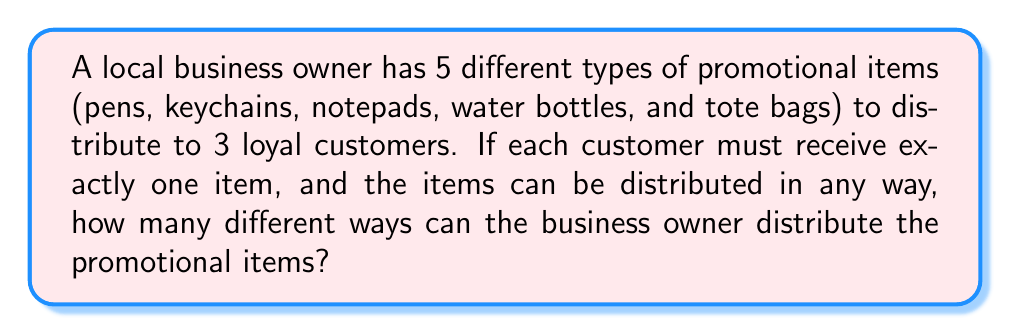Can you solve this math problem? Let's approach this step-by-step:

1) This is a permutation problem, as the order of distribution matters (each customer receives a specific item).

2) For the first customer, there are 5 choices of items.

3) After the first item is given, there are 4 choices left for the second customer.

4) For the last customer, there are 3 choices remaining.

5) According to the multiplication principle, we multiply these numbers together:

   $$5 \times 4 \times 3 = 60$$

6) This can also be expressed as a permutation:

   $$P(5,3) = \frac{5!}{(5-3)!} = \frac{5!}{2!} = 60$$

7) Here's the calculation:
   
   $$\frac{5 \times 4 \times 3 \times 2!}{2!} = \frac{120}{2} = 60$$

Therefore, there are 60 different ways to distribute the promotional items.
Answer: 60 ways 